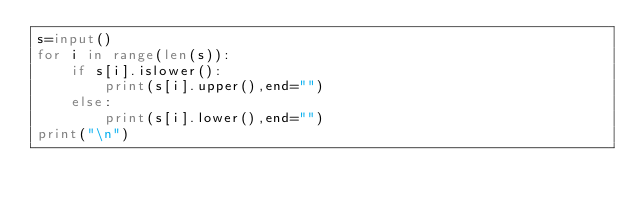Convert code to text. <code><loc_0><loc_0><loc_500><loc_500><_Python_>s=input()
for i in range(len(s)):
    if s[i].islower():
        print(s[i].upper(),end="")
    else:
        print(s[i].lower(),end="")
print("\n")
</code> 